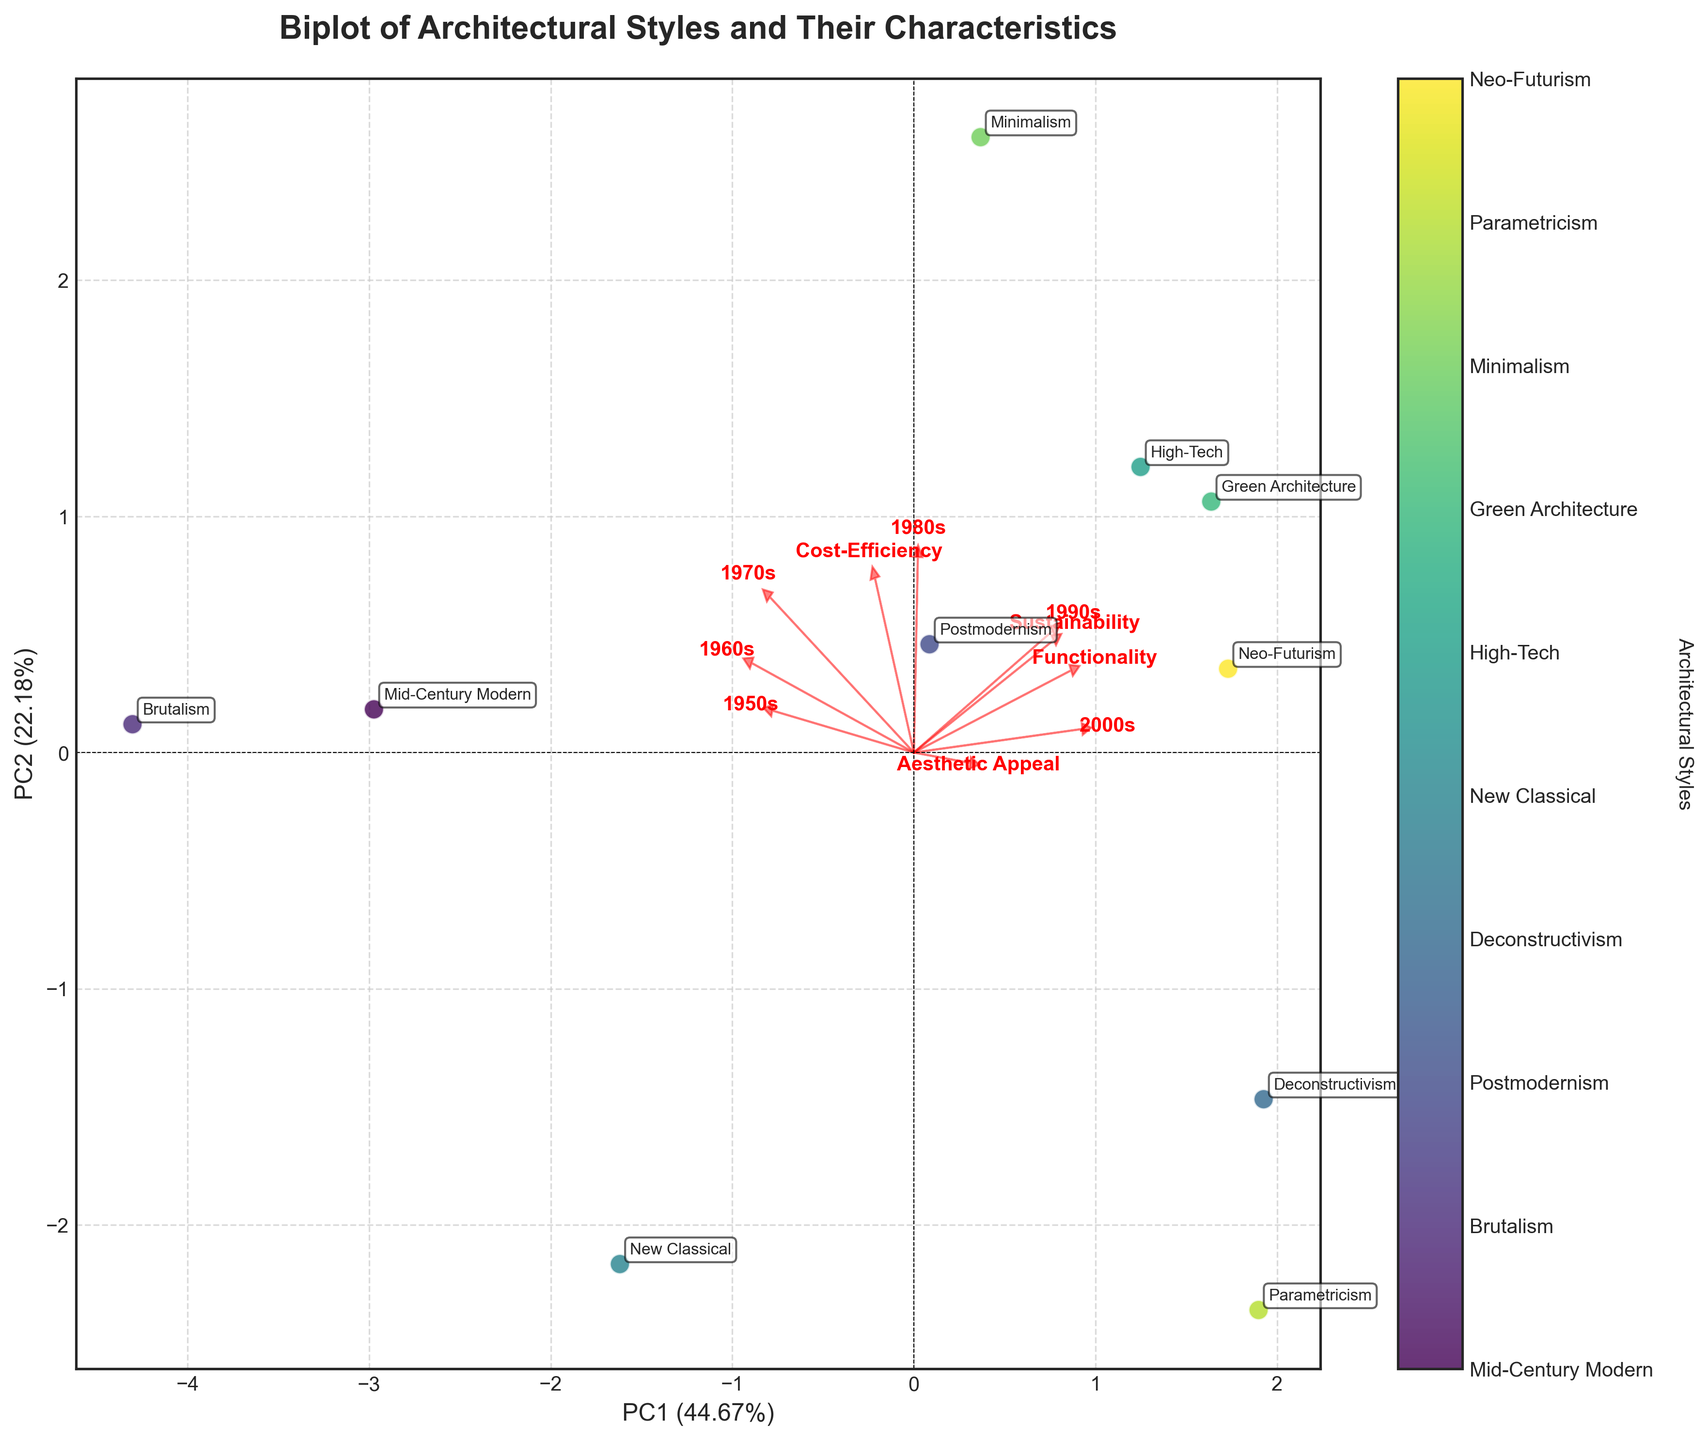How many different architectural styles are shown in the biplot? The color bar and the annotations on the plot indicate each different architectural style. Count the number of unique labels.
Answer: 10 What does the arrow labeled "Sustainability" represent in the biplot? In a biplot, arrows represent loadings of the original variables. The "Sustainability" arrow shows the direction and magnitude of the variable's contribution to the Principal Components. Longer arrows indicate a stronger influence.
Answer: Sustainability's influence on PCs Which architectural style has the highest score on PC1? Examine the x-coordinates of the points representing architectural styles; the one farthest to the right on PC1 has the highest score.
Answer: Minimalism Which two architectural styles are most similar based on the biplot? Identify points that are close to each other in both PC1 and PC2 coordinates.
Answer: Green Architecture and Parametricism Does the "Functionality" variable have a stronger correlation with PC1 or PC2? Look at the direction and length of the "Functionality" arrow. The component it more closely aligns with shows stronger correlation.
Answer: PC2 How much variance is explained by PC1? Refer to the x-axis label of the biplot, which provides the percentage of variance explained by PC1.
Answer: Approximately 47% How does "Cost-Efficiency" influence the positioning of architectural styles? Observe the direction and length of the "Cost-Efficiency" arrow; styles in that direction have higher cost-efficiency scores.
Answer: Positive influence on PC2 Which architectural style has the closest score on PC2 as Postmodernism? Check the y-coordinates of the points; find the style that aligns closely with Postmodernism's vertical position.
Answer: Deconstructivism What decade shows the most variation in the popularity of architectural styles? Consider the spread of points along the PC1 and PC2 axes; wider spread indicates more variation. Compare this against the arrows representing the decades.
Answer: 2000s 